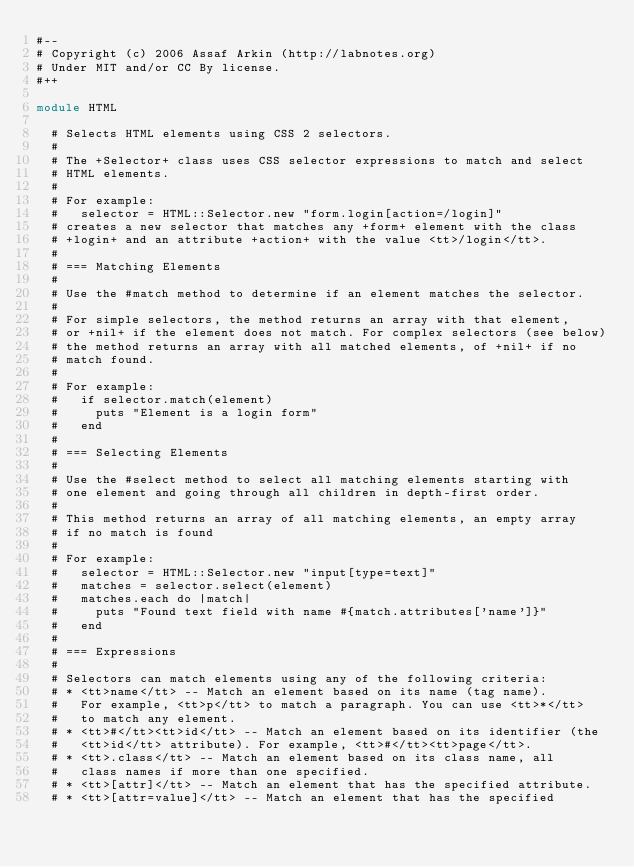<code> <loc_0><loc_0><loc_500><loc_500><_Ruby_>#--
# Copyright (c) 2006 Assaf Arkin (http://labnotes.org)
# Under MIT and/or CC By license.
#++

module HTML

  # Selects HTML elements using CSS 2 selectors.
  #
  # The +Selector+ class uses CSS selector expressions to match and select
  # HTML elements.
  #
  # For example:
  #   selector = HTML::Selector.new "form.login[action=/login]"
  # creates a new selector that matches any +form+ element with the class
  # +login+ and an attribute +action+ with the value <tt>/login</tt>.
  #
  # === Matching Elements
  #
  # Use the #match method to determine if an element matches the selector.
  #
  # For simple selectors, the method returns an array with that element,
  # or +nil+ if the element does not match. For complex selectors (see below)
  # the method returns an array with all matched elements, of +nil+ if no
  # match found.
  #
  # For example:
  #   if selector.match(element)
  #     puts "Element is a login form"
  #   end
  #
  # === Selecting Elements
  #
  # Use the #select method to select all matching elements starting with
  # one element and going through all children in depth-first order.
  #
  # This method returns an array of all matching elements, an empty array
  # if no match is found
  #
  # For example:
  #   selector = HTML::Selector.new "input[type=text]"
  #   matches = selector.select(element)
  #   matches.each do |match|
  #     puts "Found text field with name #{match.attributes['name']}"
  #   end
  #
  # === Expressions
  #
  # Selectors can match elements using any of the following criteria:
  # * <tt>name</tt> -- Match an element based on its name (tag name).
  #   For example, <tt>p</tt> to match a paragraph. You can use <tt>*</tt>
  #   to match any element.
  # * <tt>#</tt><tt>id</tt> -- Match an element based on its identifier (the
  #   <tt>id</tt> attribute). For example, <tt>#</tt><tt>page</tt>.
  # * <tt>.class</tt> -- Match an element based on its class name, all
  #   class names if more than one specified.
  # * <tt>[attr]</tt> -- Match an element that has the specified attribute.
  # * <tt>[attr=value]</tt> -- Match an element that has the specified</code> 